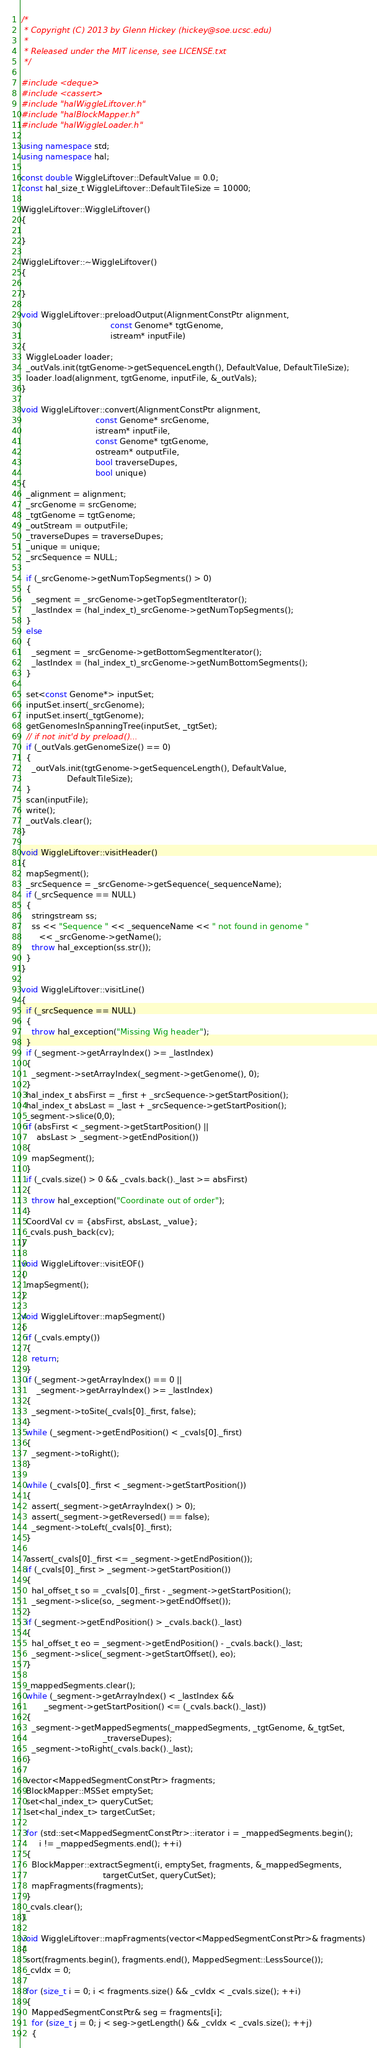<code> <loc_0><loc_0><loc_500><loc_500><_C++_>/*
 * Copyright (C) 2013 by Glenn Hickey (hickey@soe.ucsc.edu)
 *
 * Released under the MIT license, see LICENSE.txt
 */

#include <deque>
#include <cassert>
#include "halWiggleLiftover.h"
#include "halBlockMapper.h"
#include "halWiggleLoader.h"

using namespace std;
using namespace hal;

const double WiggleLiftover::DefaultValue = 0.0;
const hal_size_t WiggleLiftover::DefaultTileSize = 10000;

WiggleLiftover::WiggleLiftover()
{

}

WiggleLiftover::~WiggleLiftover()
{

}

void WiggleLiftover::preloadOutput(AlignmentConstPtr alignment,
                                   const Genome* tgtGenome,
                                   istream* inputFile)
{
  WiggleLoader loader;
  _outVals.init(tgtGenome->getSequenceLength(), DefaultValue, DefaultTileSize);
  loader.load(alignment, tgtGenome, inputFile, &_outVals);
}

void WiggleLiftover::convert(AlignmentConstPtr alignment,
                             const Genome* srcGenome,
                             istream* inputFile,
                             const Genome* tgtGenome,
                             ostream* outputFile,
                             bool traverseDupes,
                             bool unique)
{
  _alignment = alignment;
  _srcGenome = srcGenome;
  _tgtGenome = tgtGenome;
  _outStream = outputFile;
  _traverseDupes = traverseDupes;
  _unique = unique;
  _srcSequence = NULL;

  if (_srcGenome->getNumTopSegments() > 0)
  {
    _segment = _srcGenome->getTopSegmentIterator();
    _lastIndex = (hal_index_t)_srcGenome->getNumTopSegments();
  }
  else
  {
    _segment = _srcGenome->getBottomSegmentIterator();
    _lastIndex = (hal_index_t)_srcGenome->getNumBottomSegments();
  }

  set<const Genome*> inputSet;
  inputSet.insert(_srcGenome);
  inputSet.insert(_tgtGenome);
  getGenomesInSpanningTree(inputSet, _tgtSet);
  // if not init'd by preload()...
  if (_outVals.getGenomeSize() == 0)
  {
    _outVals.init(tgtGenome->getSequenceLength(), DefaultValue, 
                  DefaultTileSize);
  }
  scan(inputFile);
  write();
  _outVals.clear();
}

void WiggleLiftover::visitHeader()
{
  mapSegment();
  _srcSequence = _srcGenome->getSequence(_sequenceName);
  if (_srcSequence == NULL)
  {
    stringstream ss;
    ss << "Sequence " << _sequenceName << " not found in genome " 
       << _srcGenome->getName();
    throw hal_exception(ss.str());
  }
}

void WiggleLiftover::visitLine()
{
  if (_srcSequence == NULL)
  {
    throw hal_exception("Missing Wig header");
  }
  if (_segment->getArrayIndex() >= _lastIndex)
  {
    _segment->setArrayIndex(_segment->getGenome(), 0);
  }
  hal_index_t absFirst = _first + _srcSequence->getStartPosition();
  hal_index_t absLast = _last + _srcSequence->getStartPosition();
  _segment->slice(0,0);
  if (absFirst < _segment->getStartPosition() || 
      absLast > _segment->getEndPosition())
  {
    mapSegment();
  }
  if (_cvals.size() > 0 && _cvals.back()._last >= absFirst)
  {
    throw hal_exception("Coordinate out of order");
  }
  CoordVal cv = {absFirst, absLast, _value};
  _cvals.push_back(cv);
}
               
void WiggleLiftover::visitEOF()
{
  mapSegment();
}       

void WiggleLiftover::mapSegment()
{
  if (_cvals.empty())
  {
    return;
  }
  if (_segment->getArrayIndex() == 0 || 
      _segment->getArrayIndex() >= _lastIndex)
  {
    _segment->toSite(_cvals[0]._first, false);
  }
  while (_segment->getEndPosition() < _cvals[0]._first)
  {
    _segment->toRight();
  }

  while (_cvals[0]._first < _segment->getStartPosition())
  {
    assert(_segment->getArrayIndex() > 0);
    assert(_segment->getReversed() == false);
    _segment->toLeft(_cvals[0]._first);
  }

  assert(_cvals[0]._first <= _segment->getEndPosition());
  if (_cvals[0]._first > _segment->getStartPosition())
  {
    hal_offset_t so = _cvals[0]._first - _segment->getStartPosition();
    _segment->slice(so, _segment->getEndOffset());
  }
  if (_segment->getEndPosition() > _cvals.back()._last)
  {
    hal_offset_t eo = _segment->getEndPosition() - _cvals.back()._last;
    _segment->slice(_segment->getStartOffset(), eo);
  }

  _mappedSegments.clear();
  while (_segment->getArrayIndex() < _lastIndex &&
         _segment->getStartPosition() <= (_cvals.back()._last))
  {
    _segment->getMappedSegments(_mappedSegments, _tgtGenome, &_tgtSet,
                                _traverseDupes);  
    _segment->toRight(_cvals.back()._last);
  }

  vector<MappedSegmentConstPtr> fragments;
  BlockMapper::MSSet emptySet;
  set<hal_index_t> queryCutSet;
  set<hal_index_t> targetCutSet;
  
  for (std::set<MappedSegmentConstPtr>::iterator i = _mappedSegments.begin();
       i != _mappedSegments.end(); ++i)
  {
    BlockMapper::extractSegment(i, emptySet, fragments, &_mappedSegments, 
                                targetCutSet, queryCutSet);
    mapFragments(fragments);
  }
  _cvals.clear();
}

void WiggleLiftover::mapFragments(vector<MappedSegmentConstPtr>& fragments)
{
  sort(fragments.begin(), fragments.end(), MappedSegment::LessSource());
  _cvIdx = 0;
  
  for (size_t i = 0; i < fragments.size() && _cvIdx < _cvals.size(); ++i)
  {
    MappedSegmentConstPtr& seg = fragments[i];
    for (size_t j = 0; j < seg->getLength() && _cvIdx < _cvals.size(); ++j)
    {</code> 